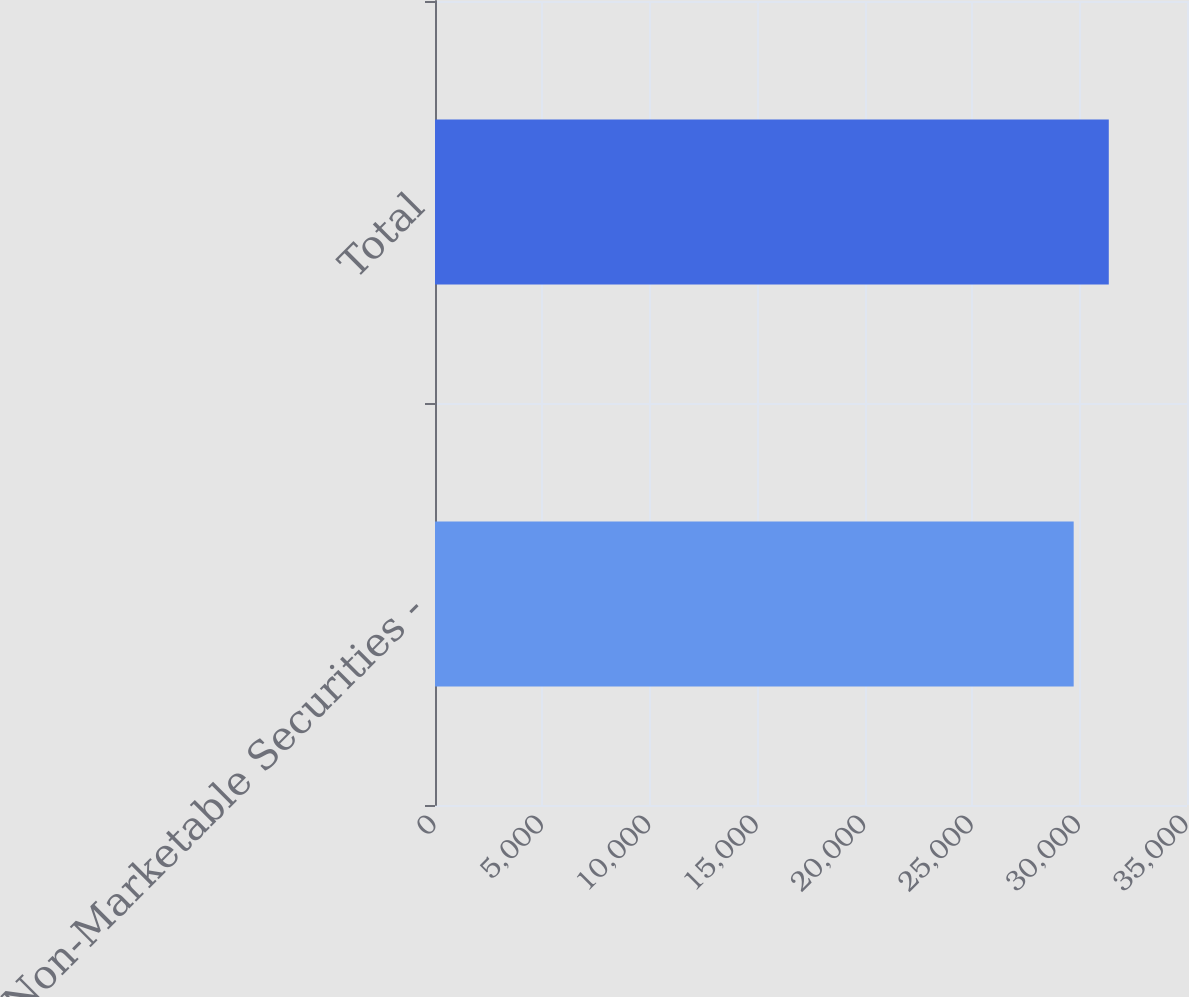Convert chart to OTSL. <chart><loc_0><loc_0><loc_500><loc_500><bar_chart><fcel>Non-Marketable Securities -<fcel>Total<nl><fcel>29726<fcel>31360<nl></chart> 